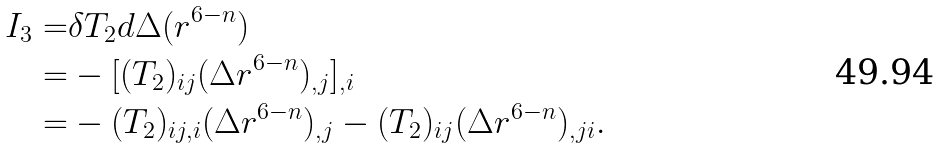<formula> <loc_0><loc_0><loc_500><loc_500>I _ { 3 } = & \delta T _ { 2 } d \Delta ( r ^ { 6 - n } ) \\ = & - [ ( T _ { 2 } ) _ { i j } ( \Delta r ^ { 6 - n } ) _ { , j } ] _ { , i } \\ = & - ( T _ { 2 } ) _ { i j , i } ( \Delta r ^ { 6 - n } ) _ { , j } - ( T _ { 2 } ) _ { i j } ( \Delta r ^ { 6 - n } ) _ { , j i } .</formula> 